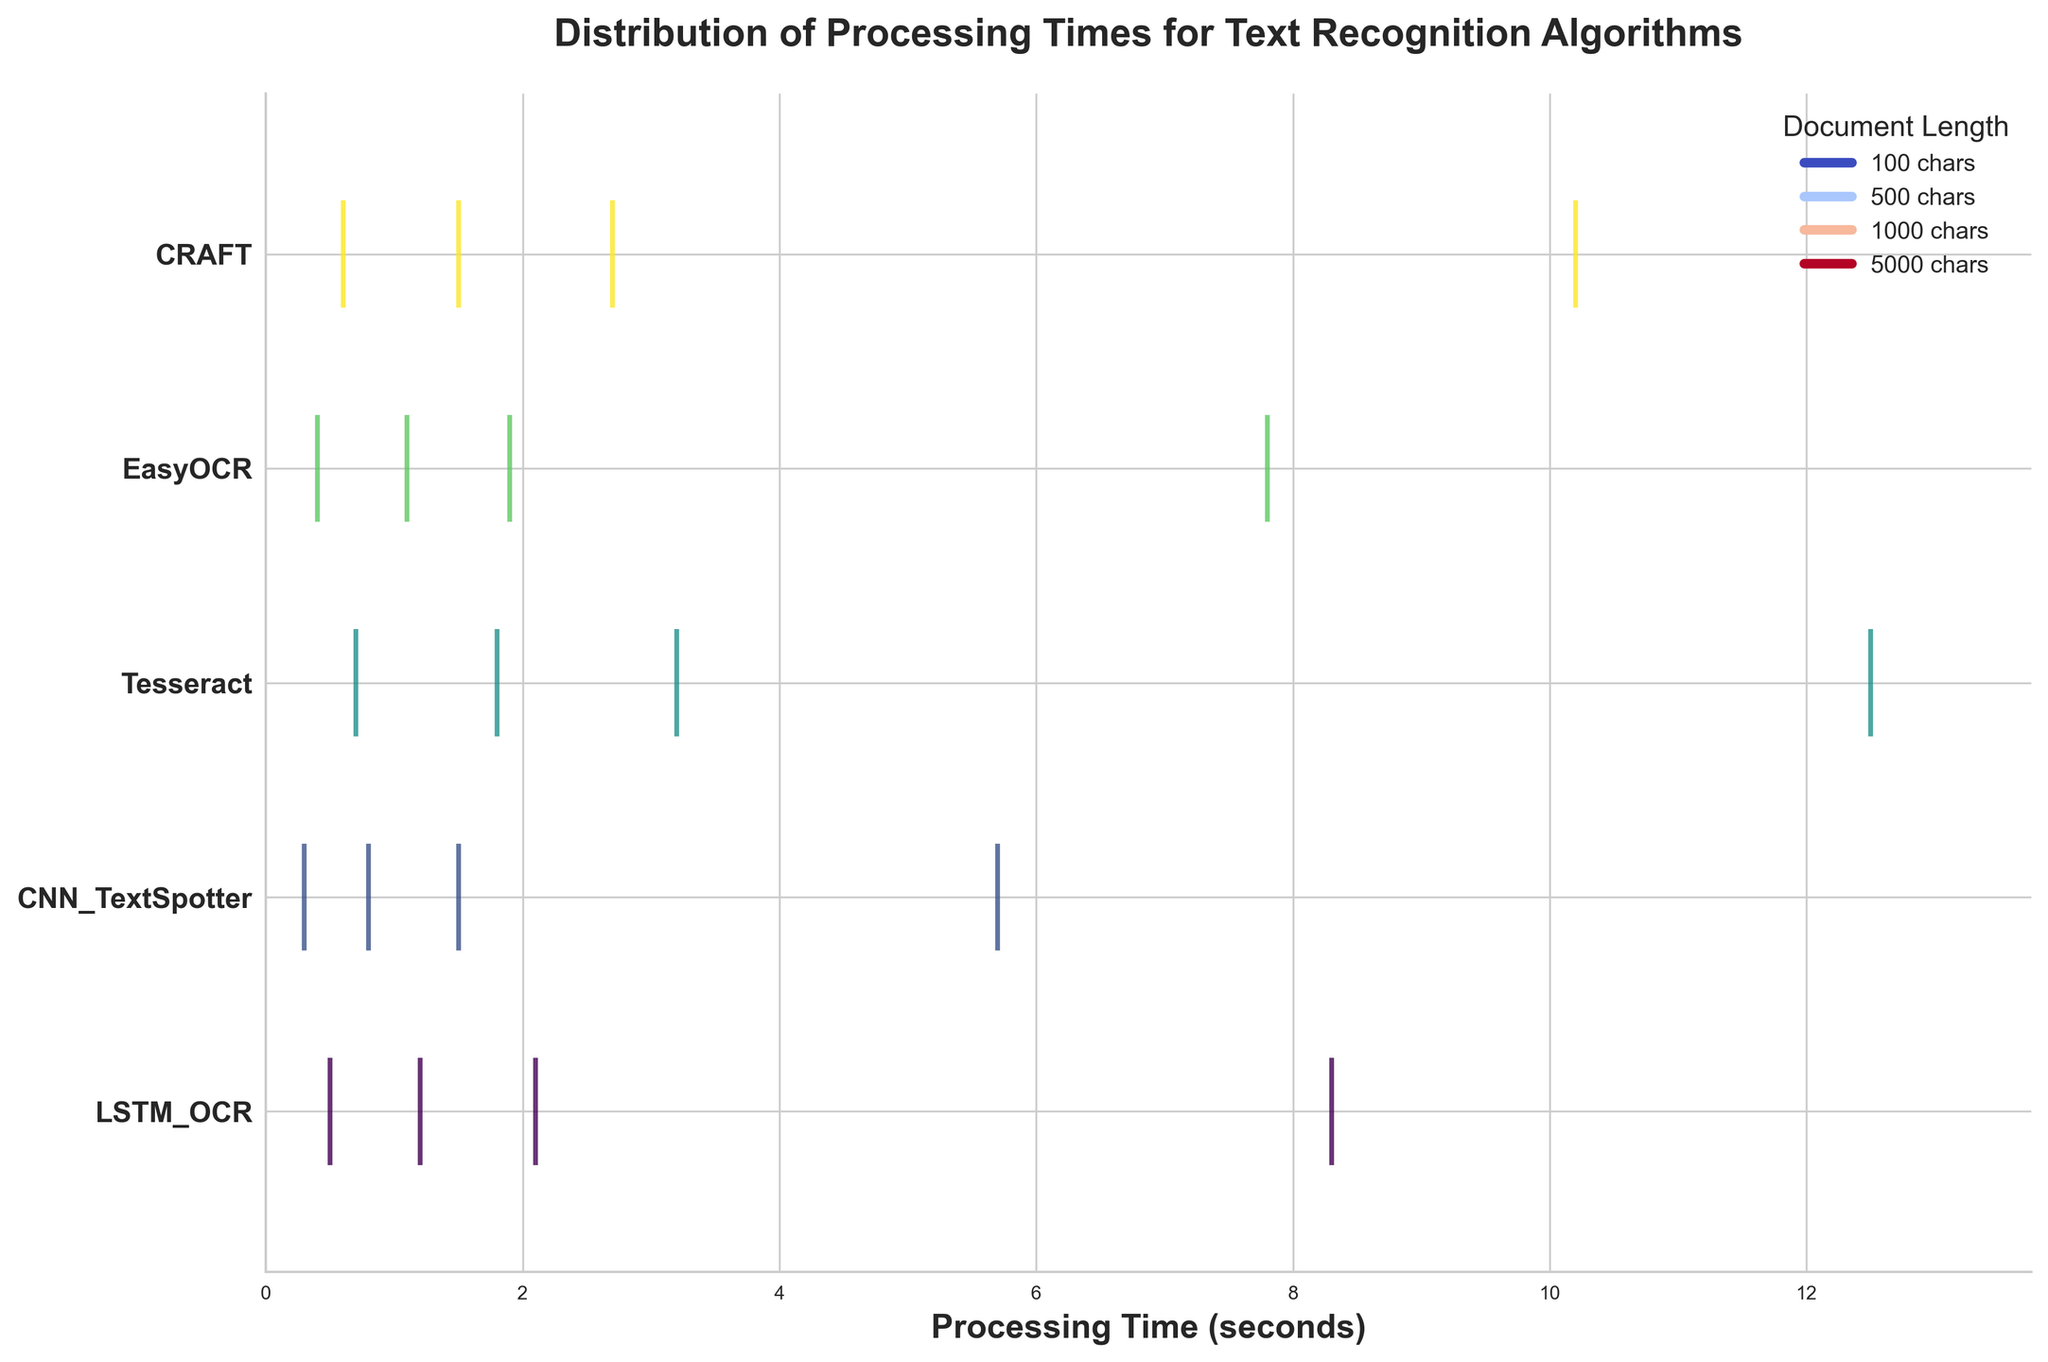What is the title of the figure? The title of the figure is displayed at the top in bold. It says, "Distribution of Processing Times for Text Recognition Algorithms".
Answer: Distribution of Processing Times for Text Recognition Algorithms How is the x-axis labeled? The x-axis label is located below the axis and it reads "Processing Time (seconds)".
Answer: Processing Time (seconds) Which algorithm has the shortest processing time for a document length of 100 characters? The eventplot shows lines for different processing times. The line closest to zero processing time in the row for an algorithm indicates the shortest time. For a document length of 100 characters, CNN_TextSpotter has the shortest time.
Answer: CNN_TextSpotter Which algorithm has the longest processing time for a document length of 5000 characters? The algorithm with the event line furthest to the right in the row for an algorithm represents the longest processing time. For 5000 characters, Tesseract has the longest time.
Answer: Tesseract Which algorithm generally shows the second longest processing times for different document lengths based on the event distribution? By observing the event distributions horizontally, CRAFT generally shows the second longest processing times across different document lengths.
Answer: CRAFT How many algorithms are compared in the figure? Count the number of distinct rows labeled with different algorithms on the y-axis. There are 5 different algorithms listed.
Answer: 5 Which algorithm demonstrates the most consistent processing times across document lengths? Consistency can be inferred from the spread of event lines. The algorithm with the closest clustering of lines exhibits the most consistent times. CNN_TextSpotter shows the most consistent processing times.
Answer: CNN_TextSpotter What is the average processing time for LSTM_OCR for the given document lengths? Identify the processing times for LSTM_OCR (0.5, 1.2, 2.1, 8.3). Calculate their average: (0.5 + 1.2 + 2.1 + 8.3) / 4 = 3.03 seconds.
Answer: 3.03 seconds Which two algorithms have processing times closest to each other for a document length of 1000 characters? Compare the event lines for 1000 characters. LSTM_OCR and EasyOCR have processing times that are closest to each other at around 2.1 and 1.9 seconds, respectively.
Answer: LSTM_OCR and EasyOCR 